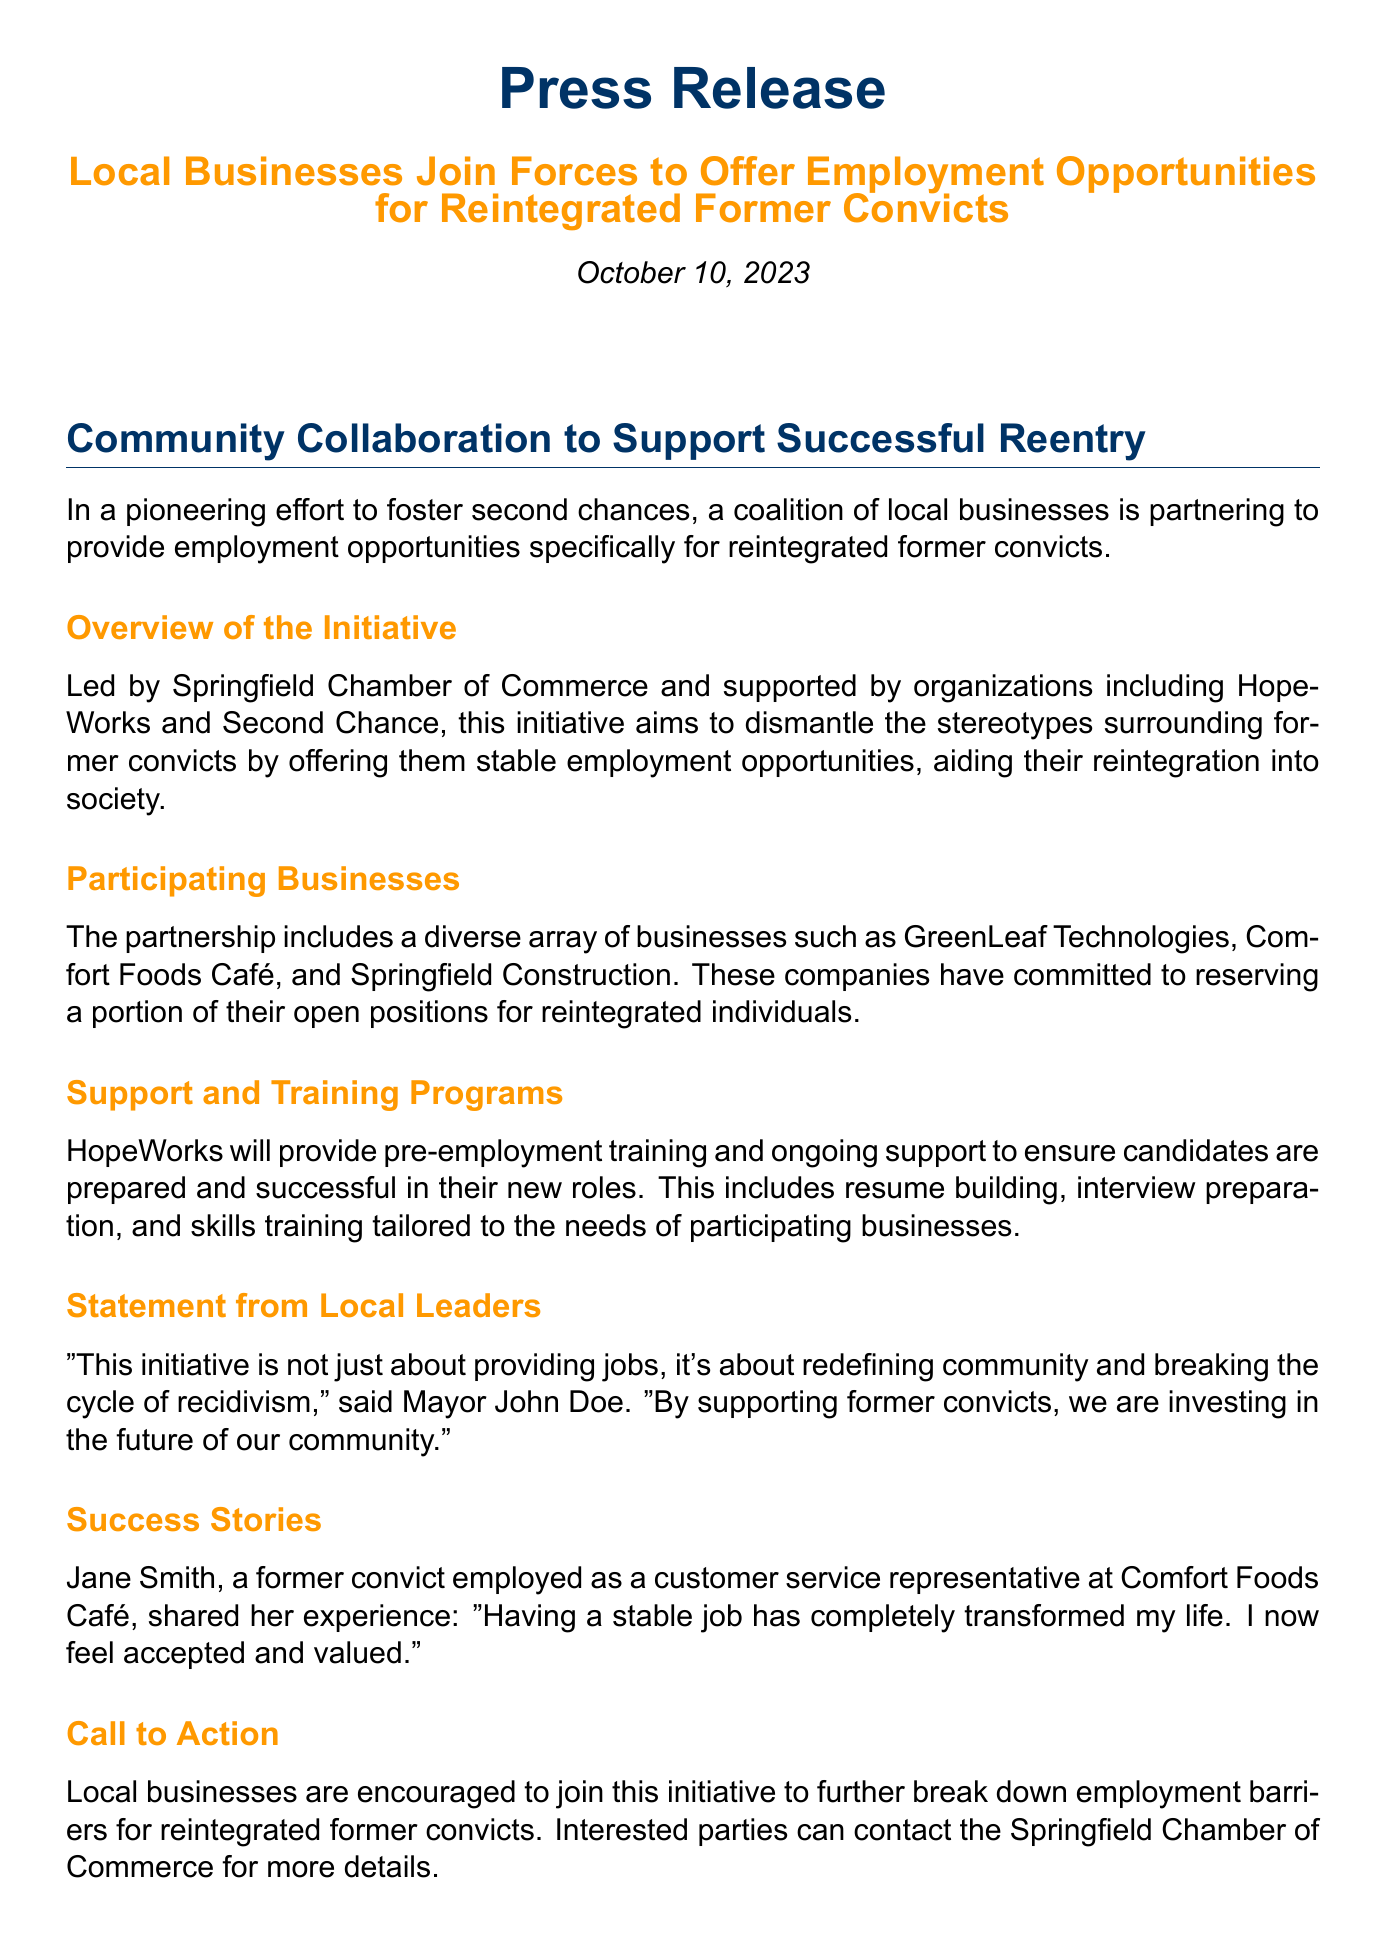What is the date of the press release? The date of the press release is stated at the top and is October 10, 2023.
Answer: October 10, 2023 Who leads the initiative? The initiative is led by the Springfield Chamber of Commerce, which is indicated in the overview section.
Answer: Springfield Chamber of Commerce What businesses are participating? The document lists specific businesses involved in the initiative, such as GreenLeaf Technologies, Comfort Foods Café, and Springfield Construction.
Answer: GreenLeaf Technologies, Comfort Foods Café, Springfield Construction What type of support will HopeWorks provide? HopeWorks offers pre-employment training and ongoing support for the candidates, as mentioned under the support and training programs section.
Answer: Pre-employment training and ongoing support Who is the local leader quoted in the press release? A direct quote is provided from a local leader, specifically Mayor John Doe.
Answer: Mayor John Doe What is the main goal of the initiative? The primary aim stated in the document is to dismantle stereotypes surrounding former convicts by providing stable employment opportunities.
Answer: Dismantle stereotypes How can local businesses participate in this initiative? The call to action section indicates that interested parties can contact the Springfield Chamber of Commerce for more details.
Answer: Contact Springfield Chamber of Commerce What is Jane Smith’s role in the initiative? The document mentions Jane Smith as a former convict who is employed as a customer service representative, sharing her success story.
Answer: Customer service representative What does the initiative aim to break? The document highlights that the initiative aims to break the cycle of recidivism, as stated in the statement from the Mayor.
Answer: Cycle of recidivism 